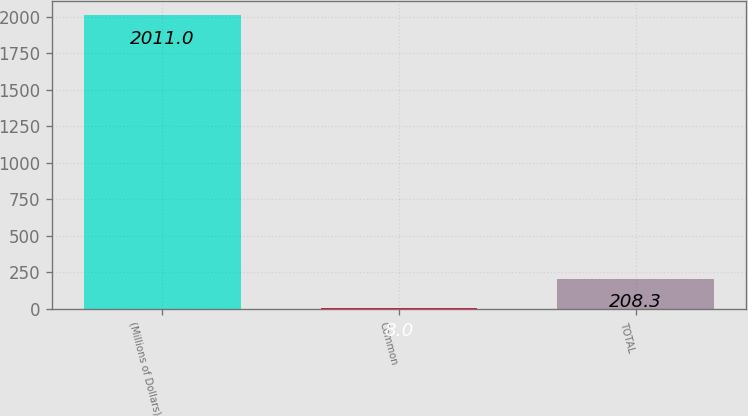<chart> <loc_0><loc_0><loc_500><loc_500><bar_chart><fcel>(Millions of Dollars)<fcel>Common<fcel>TOTAL<nl><fcel>2011<fcel>8<fcel>208.3<nl></chart> 